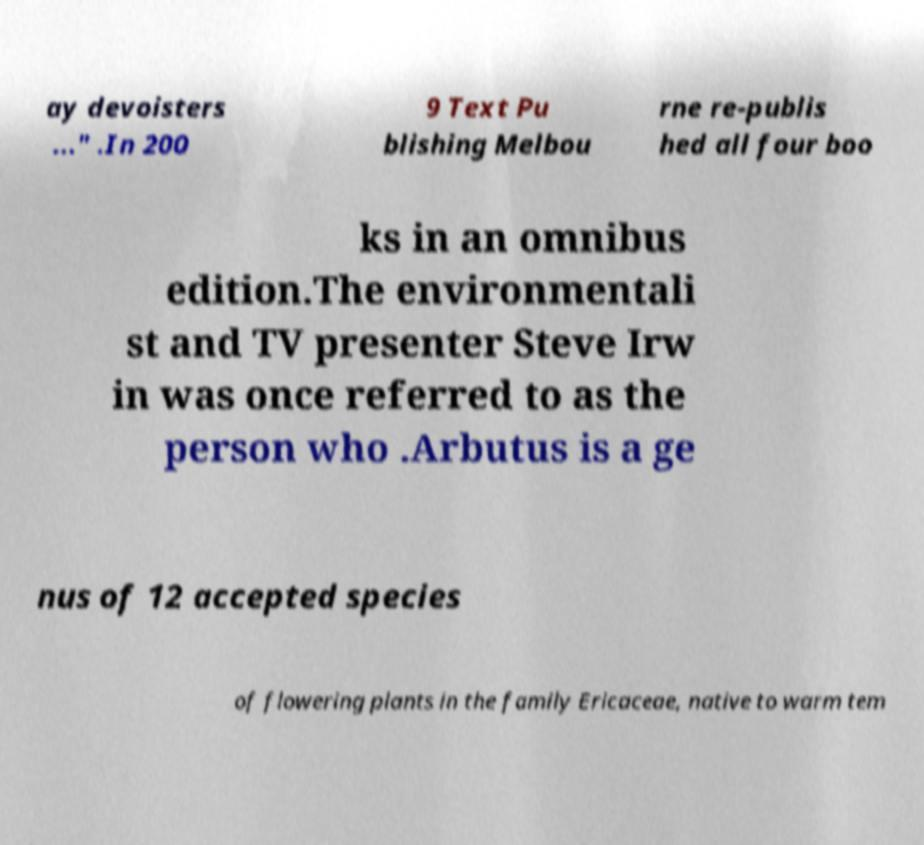I need the written content from this picture converted into text. Can you do that? ay devoisters ..." .In 200 9 Text Pu blishing Melbou rne re-publis hed all four boo ks in an omnibus edition.The environmentali st and TV presenter Steve Irw in was once referred to as the person who .Arbutus is a ge nus of 12 accepted species of flowering plants in the family Ericaceae, native to warm tem 